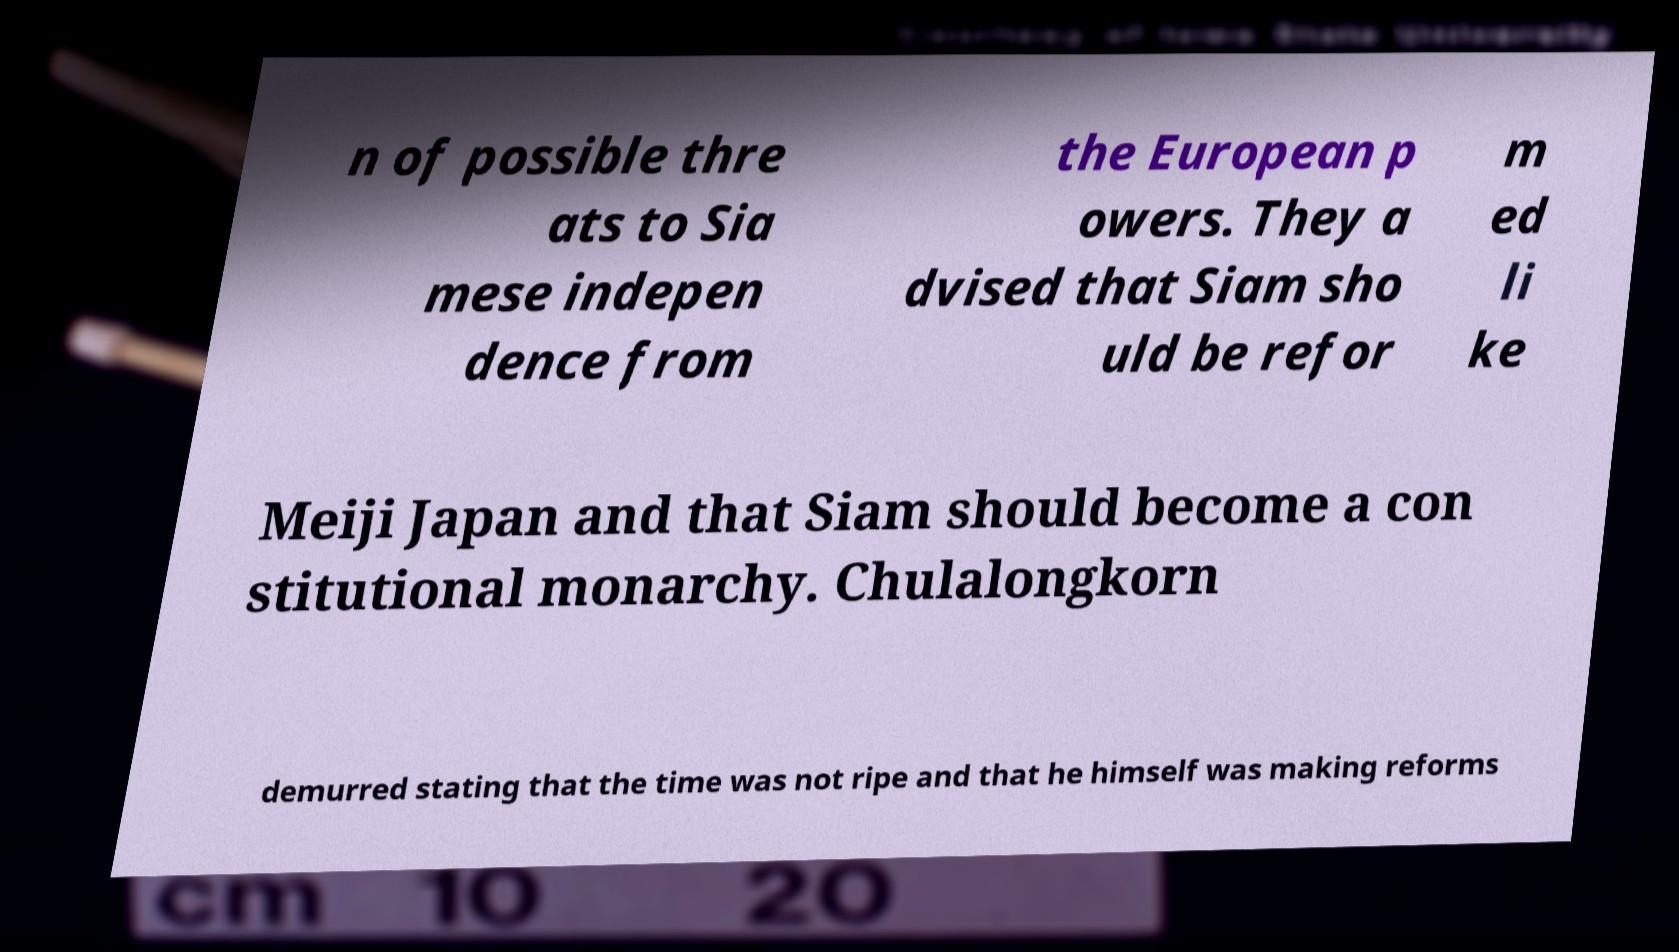Please read and relay the text visible in this image. What does it say? n of possible thre ats to Sia mese indepen dence from the European p owers. They a dvised that Siam sho uld be refor m ed li ke Meiji Japan and that Siam should become a con stitutional monarchy. Chulalongkorn demurred stating that the time was not ripe and that he himself was making reforms 